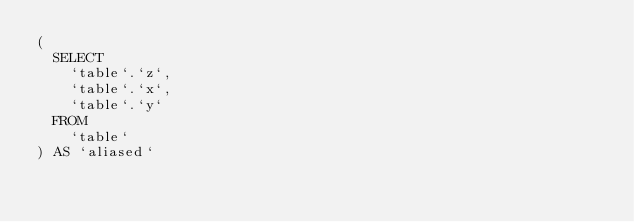Convert code to text. <code><loc_0><loc_0><loc_500><loc_500><_SQL_>(
  SELECT
    `table`.`z`,
    `table`.`x`,
    `table`.`y`
  FROM
    `table`
) AS `aliased`</code> 